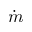<formula> <loc_0><loc_0><loc_500><loc_500>\dot { m }</formula> 